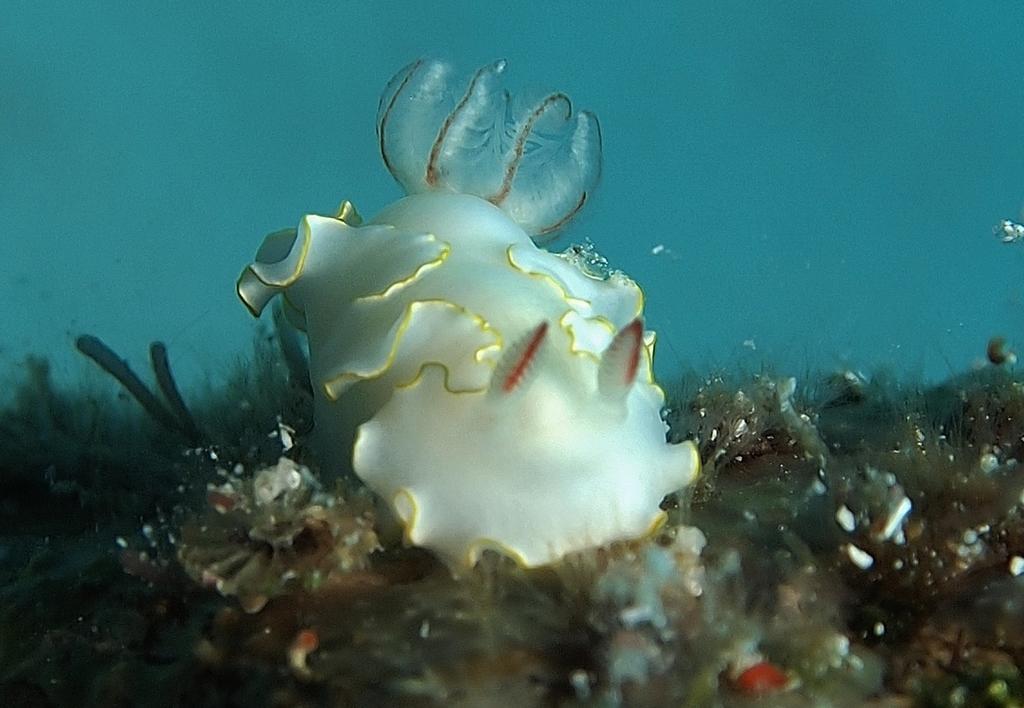Could you give a brief overview of what you see in this image? In this image I can see a fish and submarine species in the water. This image is taken may be in the ocean. 